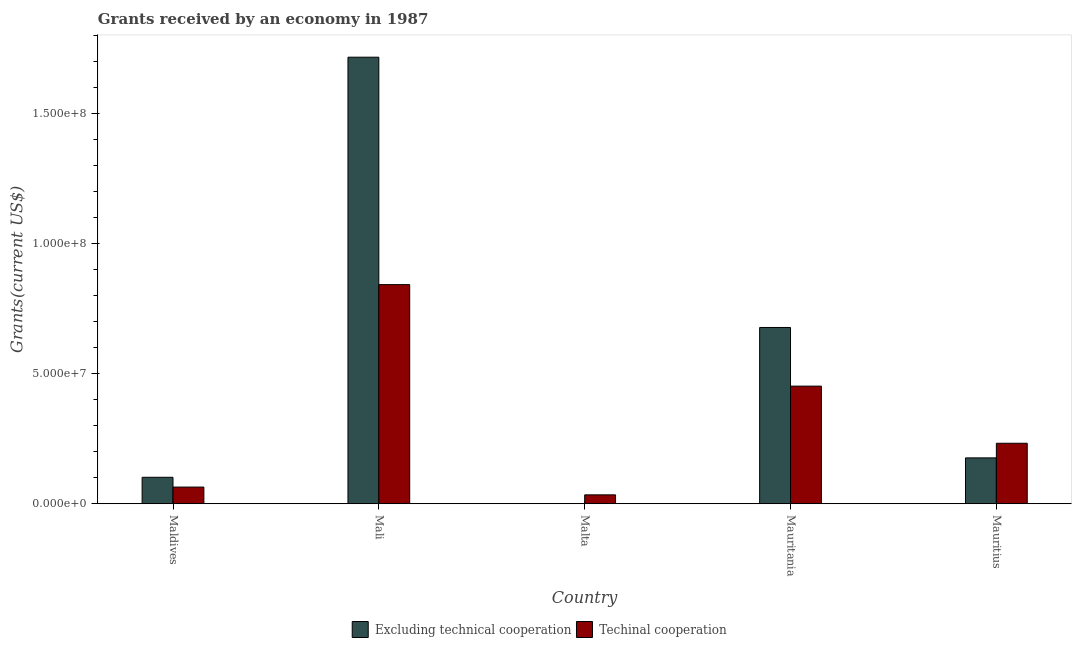How many bars are there on the 3rd tick from the right?
Make the answer very short. 2. What is the label of the 1st group of bars from the left?
Provide a short and direct response. Maldives. In how many cases, is the number of bars for a given country not equal to the number of legend labels?
Ensure brevity in your answer.  0. What is the amount of grants received(including technical cooperation) in Mali?
Ensure brevity in your answer.  8.42e+07. Across all countries, what is the maximum amount of grants received(including technical cooperation)?
Offer a very short reply. 8.42e+07. Across all countries, what is the minimum amount of grants received(excluding technical cooperation)?
Offer a terse response. 1.00e+04. In which country was the amount of grants received(excluding technical cooperation) maximum?
Your answer should be compact. Mali. In which country was the amount of grants received(including technical cooperation) minimum?
Ensure brevity in your answer.  Malta. What is the total amount of grants received(excluding technical cooperation) in the graph?
Your response must be concise. 2.67e+08. What is the difference between the amount of grants received(including technical cooperation) in Maldives and that in Mali?
Provide a short and direct response. -7.78e+07. What is the difference between the amount of grants received(excluding technical cooperation) in Mauritius and the amount of grants received(including technical cooperation) in Malta?
Keep it short and to the point. 1.42e+07. What is the average amount of grants received(including technical cooperation) per country?
Give a very brief answer. 3.25e+07. What is the difference between the amount of grants received(excluding technical cooperation) and amount of grants received(including technical cooperation) in Mauritius?
Keep it short and to the point. -5.62e+06. In how many countries, is the amount of grants received(excluding technical cooperation) greater than 20000000 US$?
Keep it short and to the point. 2. What is the ratio of the amount of grants received(excluding technical cooperation) in Mali to that in Malta?
Give a very brief answer. 1.72e+04. Is the amount of grants received(including technical cooperation) in Mali less than that in Mauritius?
Make the answer very short. No. Is the difference between the amount of grants received(excluding technical cooperation) in Maldives and Mauritania greater than the difference between the amount of grants received(including technical cooperation) in Maldives and Mauritania?
Offer a terse response. No. What is the difference between the highest and the second highest amount of grants received(including technical cooperation)?
Provide a short and direct response. 3.90e+07. What is the difference between the highest and the lowest amount of grants received(excluding technical cooperation)?
Provide a short and direct response. 1.72e+08. In how many countries, is the amount of grants received(excluding technical cooperation) greater than the average amount of grants received(excluding technical cooperation) taken over all countries?
Your answer should be very brief. 2. Is the sum of the amount of grants received(including technical cooperation) in Malta and Mauritania greater than the maximum amount of grants received(excluding technical cooperation) across all countries?
Offer a terse response. No. What does the 2nd bar from the left in Mauritania represents?
Keep it short and to the point. Techinal cooperation. What does the 1st bar from the right in Mauritania represents?
Provide a succinct answer. Techinal cooperation. How many bars are there?
Offer a terse response. 10. Are all the bars in the graph horizontal?
Keep it short and to the point. No. How many countries are there in the graph?
Provide a short and direct response. 5. What is the difference between two consecutive major ticks on the Y-axis?
Provide a short and direct response. 5.00e+07. Does the graph contain grids?
Offer a very short reply. No. How are the legend labels stacked?
Offer a very short reply. Horizontal. What is the title of the graph?
Keep it short and to the point. Grants received by an economy in 1987. What is the label or title of the X-axis?
Your answer should be very brief. Country. What is the label or title of the Y-axis?
Ensure brevity in your answer.  Grants(current US$). What is the Grants(current US$) of Excluding technical cooperation in Maldives?
Keep it short and to the point. 1.02e+07. What is the Grants(current US$) in Techinal cooperation in Maldives?
Provide a short and direct response. 6.41e+06. What is the Grants(current US$) in Excluding technical cooperation in Mali?
Provide a short and direct response. 1.72e+08. What is the Grants(current US$) in Techinal cooperation in Mali?
Provide a short and direct response. 8.42e+07. What is the Grants(current US$) in Excluding technical cooperation in Malta?
Provide a short and direct response. 1.00e+04. What is the Grants(current US$) of Techinal cooperation in Malta?
Provide a short and direct response. 3.42e+06. What is the Grants(current US$) in Excluding technical cooperation in Mauritania?
Provide a succinct answer. 6.78e+07. What is the Grants(current US$) of Techinal cooperation in Mauritania?
Give a very brief answer. 4.52e+07. What is the Grants(current US$) in Excluding technical cooperation in Mauritius?
Keep it short and to the point. 1.76e+07. What is the Grants(current US$) in Techinal cooperation in Mauritius?
Your answer should be compact. 2.32e+07. Across all countries, what is the maximum Grants(current US$) in Excluding technical cooperation?
Keep it short and to the point. 1.72e+08. Across all countries, what is the maximum Grants(current US$) in Techinal cooperation?
Offer a very short reply. 8.42e+07. Across all countries, what is the minimum Grants(current US$) in Excluding technical cooperation?
Make the answer very short. 1.00e+04. Across all countries, what is the minimum Grants(current US$) in Techinal cooperation?
Make the answer very short. 3.42e+06. What is the total Grants(current US$) of Excluding technical cooperation in the graph?
Ensure brevity in your answer.  2.67e+08. What is the total Grants(current US$) in Techinal cooperation in the graph?
Provide a short and direct response. 1.63e+08. What is the difference between the Grants(current US$) of Excluding technical cooperation in Maldives and that in Mali?
Your answer should be very brief. -1.61e+08. What is the difference between the Grants(current US$) of Techinal cooperation in Maldives and that in Mali?
Your response must be concise. -7.78e+07. What is the difference between the Grants(current US$) of Excluding technical cooperation in Maldives and that in Malta?
Make the answer very short. 1.02e+07. What is the difference between the Grants(current US$) in Techinal cooperation in Maldives and that in Malta?
Provide a short and direct response. 2.99e+06. What is the difference between the Grants(current US$) in Excluding technical cooperation in Maldives and that in Mauritania?
Give a very brief answer. -5.76e+07. What is the difference between the Grants(current US$) of Techinal cooperation in Maldives and that in Mauritania?
Keep it short and to the point. -3.88e+07. What is the difference between the Grants(current US$) of Excluding technical cooperation in Maldives and that in Mauritius?
Your answer should be very brief. -7.46e+06. What is the difference between the Grants(current US$) of Techinal cooperation in Maldives and that in Mauritius?
Give a very brief answer. -1.68e+07. What is the difference between the Grants(current US$) of Excluding technical cooperation in Mali and that in Malta?
Your response must be concise. 1.72e+08. What is the difference between the Grants(current US$) in Techinal cooperation in Mali and that in Malta?
Offer a very short reply. 8.08e+07. What is the difference between the Grants(current US$) of Excluding technical cooperation in Mali and that in Mauritania?
Provide a short and direct response. 1.04e+08. What is the difference between the Grants(current US$) in Techinal cooperation in Mali and that in Mauritania?
Give a very brief answer. 3.90e+07. What is the difference between the Grants(current US$) in Excluding technical cooperation in Mali and that in Mauritius?
Offer a very short reply. 1.54e+08. What is the difference between the Grants(current US$) of Techinal cooperation in Mali and that in Mauritius?
Offer a terse response. 6.10e+07. What is the difference between the Grants(current US$) in Excluding technical cooperation in Malta and that in Mauritania?
Your answer should be compact. -6.78e+07. What is the difference between the Grants(current US$) in Techinal cooperation in Malta and that in Mauritania?
Offer a terse response. -4.18e+07. What is the difference between the Grants(current US$) of Excluding technical cooperation in Malta and that in Mauritius?
Give a very brief answer. -1.76e+07. What is the difference between the Grants(current US$) of Techinal cooperation in Malta and that in Mauritius?
Make the answer very short. -1.98e+07. What is the difference between the Grants(current US$) of Excluding technical cooperation in Mauritania and that in Mauritius?
Keep it short and to the point. 5.01e+07. What is the difference between the Grants(current US$) in Techinal cooperation in Mauritania and that in Mauritius?
Provide a short and direct response. 2.20e+07. What is the difference between the Grants(current US$) of Excluding technical cooperation in Maldives and the Grants(current US$) of Techinal cooperation in Mali?
Offer a terse response. -7.41e+07. What is the difference between the Grants(current US$) of Excluding technical cooperation in Maldives and the Grants(current US$) of Techinal cooperation in Malta?
Your response must be concise. 6.75e+06. What is the difference between the Grants(current US$) of Excluding technical cooperation in Maldives and the Grants(current US$) of Techinal cooperation in Mauritania?
Your response must be concise. -3.50e+07. What is the difference between the Grants(current US$) of Excluding technical cooperation in Maldives and the Grants(current US$) of Techinal cooperation in Mauritius?
Ensure brevity in your answer.  -1.31e+07. What is the difference between the Grants(current US$) in Excluding technical cooperation in Mali and the Grants(current US$) in Techinal cooperation in Malta?
Provide a short and direct response. 1.68e+08. What is the difference between the Grants(current US$) of Excluding technical cooperation in Mali and the Grants(current US$) of Techinal cooperation in Mauritania?
Ensure brevity in your answer.  1.26e+08. What is the difference between the Grants(current US$) of Excluding technical cooperation in Mali and the Grants(current US$) of Techinal cooperation in Mauritius?
Ensure brevity in your answer.  1.48e+08. What is the difference between the Grants(current US$) in Excluding technical cooperation in Malta and the Grants(current US$) in Techinal cooperation in Mauritania?
Provide a succinct answer. -4.52e+07. What is the difference between the Grants(current US$) in Excluding technical cooperation in Malta and the Grants(current US$) in Techinal cooperation in Mauritius?
Provide a succinct answer. -2.32e+07. What is the difference between the Grants(current US$) of Excluding technical cooperation in Mauritania and the Grants(current US$) of Techinal cooperation in Mauritius?
Provide a succinct answer. 4.45e+07. What is the average Grants(current US$) of Excluding technical cooperation per country?
Make the answer very short. 5.34e+07. What is the average Grants(current US$) of Techinal cooperation per country?
Give a very brief answer. 3.25e+07. What is the difference between the Grants(current US$) in Excluding technical cooperation and Grants(current US$) in Techinal cooperation in Maldives?
Keep it short and to the point. 3.76e+06. What is the difference between the Grants(current US$) in Excluding technical cooperation and Grants(current US$) in Techinal cooperation in Mali?
Your response must be concise. 8.74e+07. What is the difference between the Grants(current US$) in Excluding technical cooperation and Grants(current US$) in Techinal cooperation in Malta?
Provide a succinct answer. -3.41e+06. What is the difference between the Grants(current US$) of Excluding technical cooperation and Grants(current US$) of Techinal cooperation in Mauritania?
Ensure brevity in your answer.  2.26e+07. What is the difference between the Grants(current US$) of Excluding technical cooperation and Grants(current US$) of Techinal cooperation in Mauritius?
Your answer should be compact. -5.62e+06. What is the ratio of the Grants(current US$) in Excluding technical cooperation in Maldives to that in Mali?
Offer a very short reply. 0.06. What is the ratio of the Grants(current US$) of Techinal cooperation in Maldives to that in Mali?
Ensure brevity in your answer.  0.08. What is the ratio of the Grants(current US$) of Excluding technical cooperation in Maldives to that in Malta?
Your answer should be compact. 1017. What is the ratio of the Grants(current US$) in Techinal cooperation in Maldives to that in Malta?
Give a very brief answer. 1.87. What is the ratio of the Grants(current US$) of Excluding technical cooperation in Maldives to that in Mauritania?
Give a very brief answer. 0.15. What is the ratio of the Grants(current US$) in Techinal cooperation in Maldives to that in Mauritania?
Your response must be concise. 0.14. What is the ratio of the Grants(current US$) in Excluding technical cooperation in Maldives to that in Mauritius?
Ensure brevity in your answer.  0.58. What is the ratio of the Grants(current US$) in Techinal cooperation in Maldives to that in Mauritius?
Offer a very short reply. 0.28. What is the ratio of the Grants(current US$) of Excluding technical cooperation in Mali to that in Malta?
Your answer should be compact. 1.72e+04. What is the ratio of the Grants(current US$) of Techinal cooperation in Mali to that in Malta?
Offer a terse response. 24.63. What is the ratio of the Grants(current US$) of Excluding technical cooperation in Mali to that in Mauritania?
Your response must be concise. 2.53. What is the ratio of the Grants(current US$) of Techinal cooperation in Mali to that in Mauritania?
Give a very brief answer. 1.86. What is the ratio of the Grants(current US$) in Excluding technical cooperation in Mali to that in Mauritius?
Provide a short and direct response. 9.74. What is the ratio of the Grants(current US$) in Techinal cooperation in Mali to that in Mauritius?
Offer a terse response. 3.62. What is the ratio of the Grants(current US$) of Excluding technical cooperation in Malta to that in Mauritania?
Give a very brief answer. 0. What is the ratio of the Grants(current US$) of Techinal cooperation in Malta to that in Mauritania?
Provide a succinct answer. 0.08. What is the ratio of the Grants(current US$) of Excluding technical cooperation in Malta to that in Mauritius?
Ensure brevity in your answer.  0. What is the ratio of the Grants(current US$) of Techinal cooperation in Malta to that in Mauritius?
Your answer should be very brief. 0.15. What is the ratio of the Grants(current US$) of Excluding technical cooperation in Mauritania to that in Mauritius?
Your response must be concise. 3.84. What is the ratio of the Grants(current US$) of Techinal cooperation in Mauritania to that in Mauritius?
Provide a succinct answer. 1.94. What is the difference between the highest and the second highest Grants(current US$) of Excluding technical cooperation?
Offer a terse response. 1.04e+08. What is the difference between the highest and the second highest Grants(current US$) in Techinal cooperation?
Provide a short and direct response. 3.90e+07. What is the difference between the highest and the lowest Grants(current US$) of Excluding technical cooperation?
Your response must be concise. 1.72e+08. What is the difference between the highest and the lowest Grants(current US$) of Techinal cooperation?
Your answer should be very brief. 8.08e+07. 